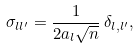<formula> <loc_0><loc_0><loc_500><loc_500>\sigma _ { l l ^ { \prime } } = \frac { 1 } { 2 a _ { l } \sqrt { n } } \, \delta _ { l , l ^ { \prime } } ,</formula> 